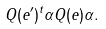<formula> <loc_0><loc_0><loc_500><loc_500>Q ( e ^ { \prime } ) ^ { t } \alpha Q ( e ) \alpha .</formula> 